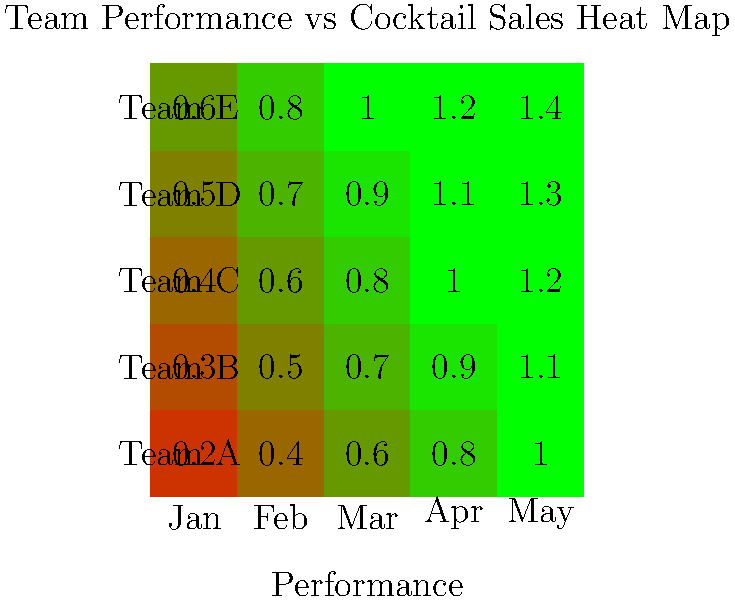Based on the heat map showing the correlation between team performance and sports-themed cocktail sales, which team consistently demonstrates the strongest positive relationship between their performance and cocktail sales throughout the five-month period? To answer this question, we need to analyze the heat map data for each team across the five months:

1. The heat map uses color intensity to represent the strength of the correlation between team performance and cocktail sales.
2. Darker green indicates a stronger positive correlation, while lighter colors (towards red) indicate a weaker correlation.
3. We need to look at the color progression for each team (row) from January to May:

Team A: 0.2 → 0.4 → 0.6 → 0.8 → 1.0
Team B: 0.3 → 0.5 → 0.7 → 0.9 → 1.1
Team C: 0.4 → 0.6 → 0.8 → 1.0 → 1.2
Team D: 0.5 → 0.7 → 0.9 → 1.1 → 1.3
Team E: 0.6 → 0.8 → 1.0 → 1.2 → 1.4

4. Team E shows the highest values and the darkest green colors consistently across all months.
5. This indicates that Team E has the strongest and most consistent positive relationship between their performance and cocktail sales.

Therefore, Team E demonstrates the strongest positive relationship between their performance and cocktail sales throughout the five-month period.
Answer: Team E 